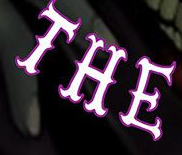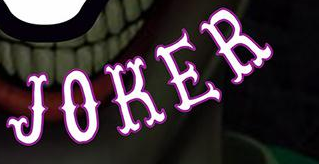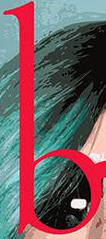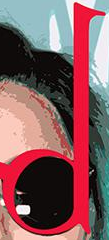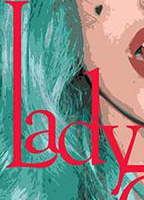Identify the words shown in these images in order, separated by a semicolon. THE; JOKER; b; d; Lady 